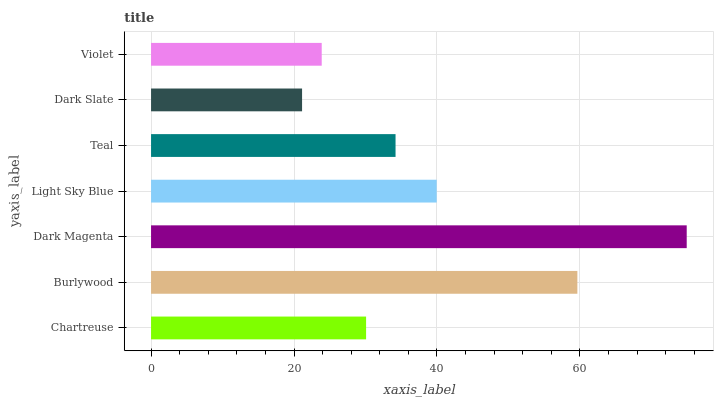Is Dark Slate the minimum?
Answer yes or no. Yes. Is Dark Magenta the maximum?
Answer yes or no. Yes. Is Burlywood the minimum?
Answer yes or no. No. Is Burlywood the maximum?
Answer yes or no. No. Is Burlywood greater than Chartreuse?
Answer yes or no. Yes. Is Chartreuse less than Burlywood?
Answer yes or no. Yes. Is Chartreuse greater than Burlywood?
Answer yes or no. No. Is Burlywood less than Chartreuse?
Answer yes or no. No. Is Teal the high median?
Answer yes or no. Yes. Is Teal the low median?
Answer yes or no. Yes. Is Violet the high median?
Answer yes or no. No. Is Dark Magenta the low median?
Answer yes or no. No. 